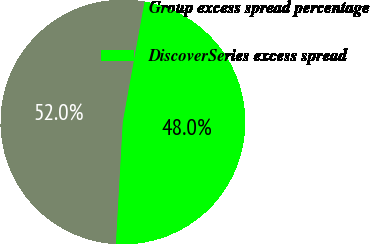Convert chart. <chart><loc_0><loc_0><loc_500><loc_500><pie_chart><fcel>Group excess spread percentage<fcel>DiscoverSeries excess spread<nl><fcel>51.95%<fcel>48.05%<nl></chart> 